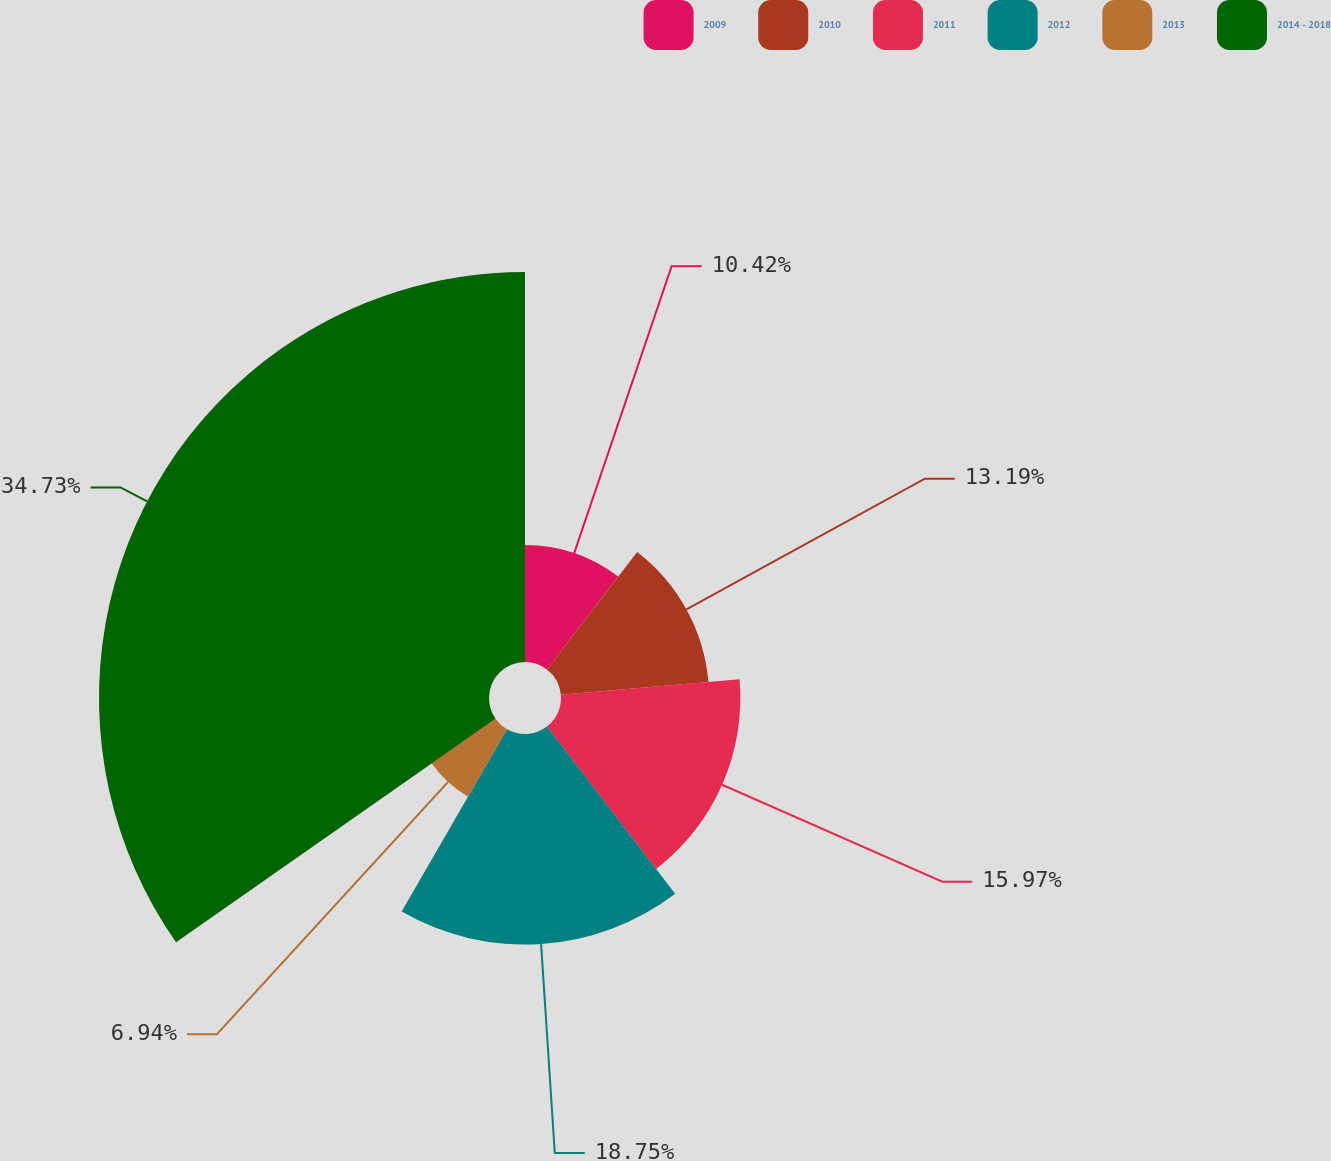Convert chart. <chart><loc_0><loc_0><loc_500><loc_500><pie_chart><fcel>2009<fcel>2010<fcel>2011<fcel>2012<fcel>2013<fcel>2014 - 2018<nl><fcel>10.42%<fcel>13.19%<fcel>15.97%<fcel>18.75%<fcel>6.94%<fcel>34.72%<nl></chart> 